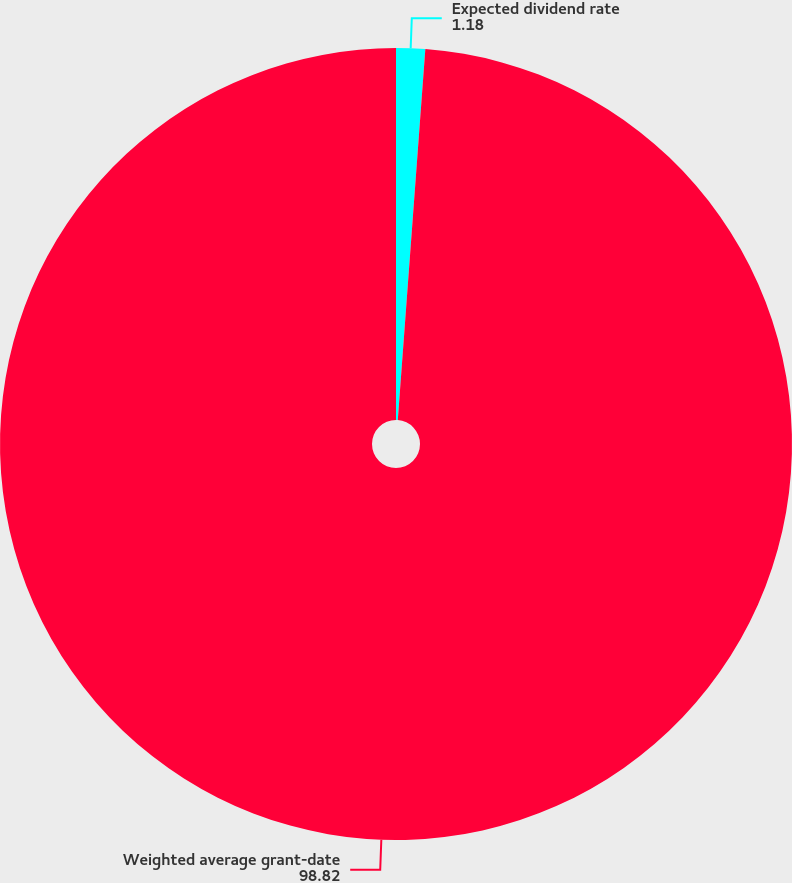Convert chart to OTSL. <chart><loc_0><loc_0><loc_500><loc_500><pie_chart><fcel>Expected dividend rate<fcel>Weighted average grant-date<nl><fcel>1.18%<fcel>98.82%<nl></chart> 